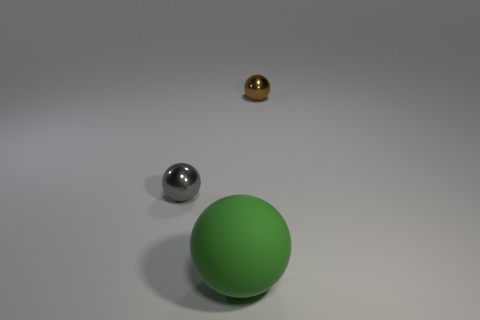Subtract all metallic spheres. How many spheres are left? 1 Add 3 gray shiny things. How many objects exist? 6 Subtract all brown spheres. How many spheres are left? 2 Subtract all big things. Subtract all small gray spheres. How many objects are left? 1 Add 3 brown metal spheres. How many brown metal spheres are left? 4 Add 3 cyan shiny cylinders. How many cyan shiny cylinders exist? 3 Subtract 1 brown balls. How many objects are left? 2 Subtract 3 spheres. How many spheres are left? 0 Subtract all gray spheres. Subtract all gray cubes. How many spheres are left? 2 